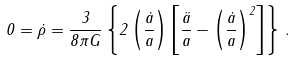<formula> <loc_0><loc_0><loc_500><loc_500>0 = \dot { \rho } = \frac { 3 } { 8 \pi G } \left \{ 2 \left ( \frac { \dot { a } } { a } \right ) \left [ \frac { \ddot { a } } { a } - \left ( \frac { \dot { a } } { a } \right ) ^ { 2 } \right ] \right \} \, .</formula> 